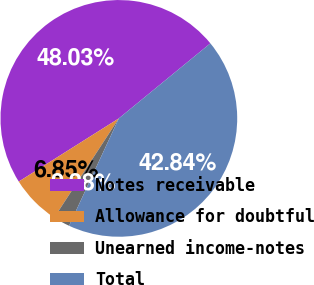<chart> <loc_0><loc_0><loc_500><loc_500><pie_chart><fcel>Notes receivable<fcel>Allowance for doubtful<fcel>Unearned income-notes<fcel>Total<nl><fcel>48.03%<fcel>6.85%<fcel>2.28%<fcel>42.84%<nl></chart> 